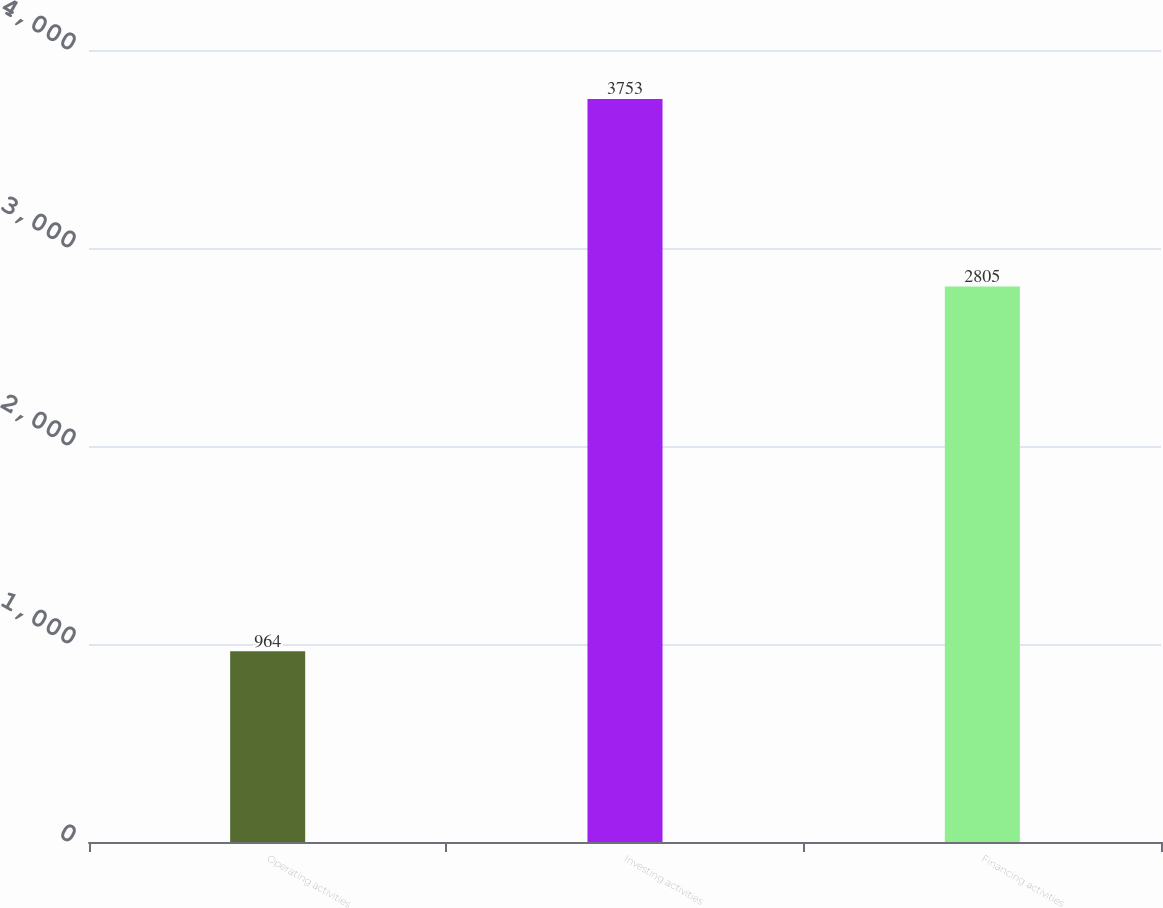<chart> <loc_0><loc_0><loc_500><loc_500><bar_chart><fcel>Operating activities<fcel>Investing activities<fcel>Financing activities<nl><fcel>964<fcel>3753<fcel>2805<nl></chart> 